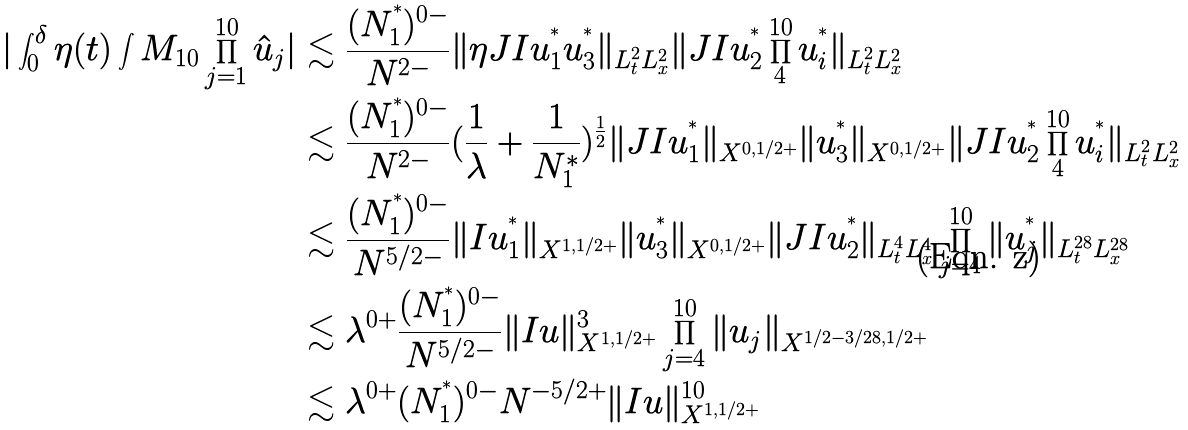Convert formula to latex. <formula><loc_0><loc_0><loc_500><loc_500>| \int _ { 0 } ^ { \delta } \eta ( t ) \int M _ { 1 0 } \prod _ { j = 1 } ^ { 1 0 } \hat { u } _ { j } | & \lesssim \frac { ( N _ { 1 } ^ { ^ { * } } ) ^ { 0 - } } { N ^ { 2 - } } \| \eta J I u _ { 1 } ^ { ^ { * } } u _ { 3 } ^ { ^ { * } } \| _ { L ^ { 2 } _ { t } L ^ { 2 } _ { x } } \| J I u _ { 2 } ^ { ^ { * } } \prod _ { 4 } ^ { 1 0 } u _ { i } ^ { ^ { * } } \| _ { L ^ { 2 } _ { t } L ^ { 2 } _ { x } } \\ & \lesssim \frac { ( N _ { 1 } ^ { ^ { * } } ) ^ { 0 - } } { N ^ { 2 - } } ( \frac { 1 } { \lambda } + \frac { 1 } { N _ { 1 } ^ { * } } ) ^ { \frac { 1 } { 2 } } \| J I u _ { 1 } ^ { ^ { * } } \| _ { X ^ { 0 , 1 / 2 + } } \| u _ { 3 } ^ { ^ { * } } \| _ { X ^ { 0 , 1 / 2 + } } \| J I u _ { 2 } ^ { ^ { * } } \prod _ { 4 } ^ { 1 0 } u _ { i } ^ { ^ { * } } \| _ { L ^ { 2 } _ { t } L ^ { 2 } _ { x } } \\ & \lesssim \frac { ( N _ { 1 } ^ { ^ { * } } ) ^ { 0 - } } { N ^ { 5 / 2 - } } \| I u _ { 1 } ^ { ^ { * } } \| _ { X ^ { 1 , 1 / 2 + } } \| u _ { 3 } ^ { ^ { * } } \| _ { X ^ { 0 , 1 / 2 + } } \| J I u _ { 2 } ^ { ^ { * } } \| _ { L ^ { 4 } _ { t } L ^ { 4 } _ { x } } \prod _ { j = 4 } ^ { 1 0 } \| u _ { j } ^ { ^ { * } } \| _ { L ^ { 2 8 } _ { t } L ^ { 2 8 } _ { x } } \\ & \lesssim \lambda ^ { 0 + } \frac { ( N _ { 1 } ^ { ^ { * } } ) ^ { 0 - } } { N ^ { 5 / 2 - } } \| I u \| _ { X ^ { 1 , 1 / 2 + } } ^ { 3 } \prod _ { j = 4 } ^ { 1 0 } \| u _ { j } \| _ { X ^ { 1 / 2 - 3 / 2 8 , 1 / 2 + } } \\ & \lesssim \lambda ^ { 0 + } ( N _ { 1 } ^ { ^ { * } } ) ^ { 0 - } N ^ { - 5 / 2 + } \| I u \| _ { X ^ { 1 , 1 / 2 + } } ^ { 1 0 }</formula> 